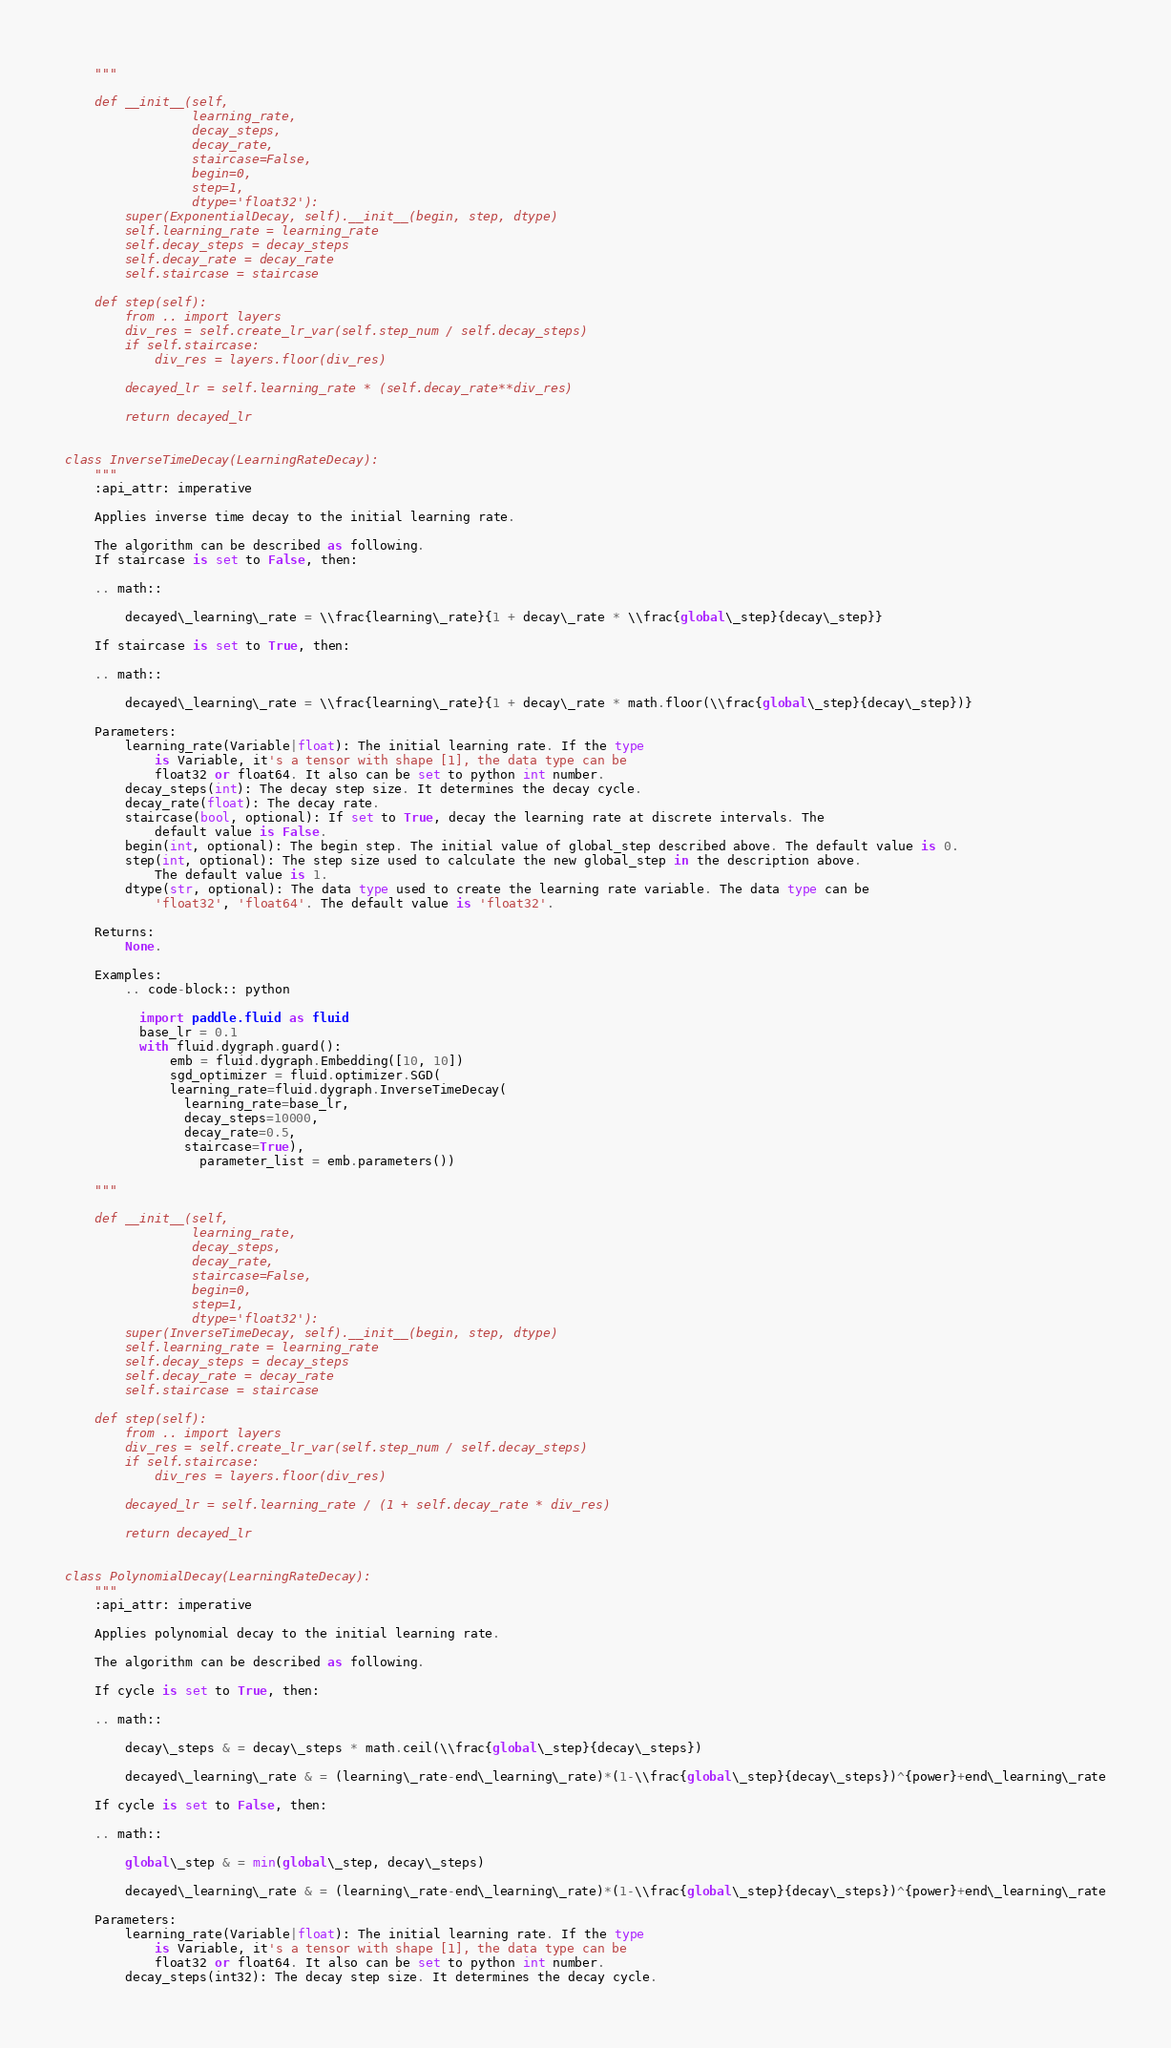Convert code to text. <code><loc_0><loc_0><loc_500><loc_500><_Python_>
    """

    def __init__(self,
                 learning_rate,
                 decay_steps,
                 decay_rate,
                 staircase=False,
                 begin=0,
                 step=1,
                 dtype='float32'):
        super(ExponentialDecay, self).__init__(begin, step, dtype)
        self.learning_rate = learning_rate
        self.decay_steps = decay_steps
        self.decay_rate = decay_rate
        self.staircase = staircase

    def step(self):
        from .. import layers
        div_res = self.create_lr_var(self.step_num / self.decay_steps)
        if self.staircase:
            div_res = layers.floor(div_res)

        decayed_lr = self.learning_rate * (self.decay_rate**div_res)

        return decayed_lr


class InverseTimeDecay(LearningRateDecay):
    """
    :api_attr: imperative

    Applies inverse time decay to the initial learning rate.

    The algorithm can be described as following.
    If staircase is set to False, then:

    .. math::

        decayed\_learning\_rate = \\frac{learning\_rate}{1 + decay\_rate * \\frac{global\_step}{decay\_step}}  

    If staircase is set to True, then:

    .. math::

        decayed\_learning\_rate = \\frac{learning\_rate}{1 + decay\_rate * math.floor(\\frac{global\_step}{decay\_step})}

    Parameters:
        learning_rate(Variable|float): The initial learning rate. If the type 
            is Variable, it's a tensor with shape [1], the data type can be  
            float32 or float64. It also can be set to python int number.
        decay_steps(int): The decay step size. It determines the decay cycle.
        decay_rate(float): The decay rate.
        staircase(bool, optional): If set to True, decay the learning rate at discrete intervals. The 
            default value is False.
        begin(int, optional): The begin step. The initial value of global_step described above. The default value is 0.
        step(int, optional): The step size used to calculate the new global_step in the description above.
            The default value is 1.
        dtype(str, optional): The data type used to create the learning rate variable. The data type can be 
            'float32', 'float64'. The default value is 'float32'.

    Returns:
        None.

    Examples:
        .. code-block:: python

          import paddle.fluid as fluid
          base_lr = 0.1
          with fluid.dygraph.guard():
              emb = fluid.dygraph.Embedding([10, 10])
              sgd_optimizer = fluid.optimizer.SGD(
	          learning_rate=fluid.dygraph.InverseTimeDecay(
		        learning_rate=base_lr,
		        decay_steps=10000,
		        decay_rate=0.5,
		        staircase=True),
                  parameter_list = emb.parameters())

    """

    def __init__(self,
                 learning_rate,
                 decay_steps,
                 decay_rate,
                 staircase=False,
                 begin=0,
                 step=1,
                 dtype='float32'):
        super(InverseTimeDecay, self).__init__(begin, step, dtype)
        self.learning_rate = learning_rate
        self.decay_steps = decay_steps
        self.decay_rate = decay_rate
        self.staircase = staircase

    def step(self):
        from .. import layers
        div_res = self.create_lr_var(self.step_num / self.decay_steps)
        if self.staircase:
            div_res = layers.floor(div_res)

        decayed_lr = self.learning_rate / (1 + self.decay_rate * div_res)

        return decayed_lr


class PolynomialDecay(LearningRateDecay):
    """
    :api_attr: imperative

    Applies polynomial decay to the initial learning rate.

    The algorithm can be described as following.

    If cycle is set to True, then:

    .. math::

        decay\_steps & = decay\_steps * math.ceil(\\frac{global\_step}{decay\_steps}) 

        decayed\_learning\_rate & = (learning\_rate-end\_learning\_rate)*(1-\\frac{global\_step}{decay\_steps})^{power}+end\_learning\_rate

    If cycle is set to False, then:

    .. math::

        global\_step & = min(global\_step, decay\_steps) 

        decayed\_learning\_rate & = (learning\_rate-end\_learning\_rate)*(1-\\frac{global\_step}{decay\_steps})^{power}+end\_learning\_rate

    Parameters:
        learning_rate(Variable|float): The initial learning rate. If the type 
            is Variable, it's a tensor with shape [1], the data type can be  
            float32 or float64. It also can be set to python int number.
        decay_steps(int32): The decay step size. It determines the decay cycle.</code> 